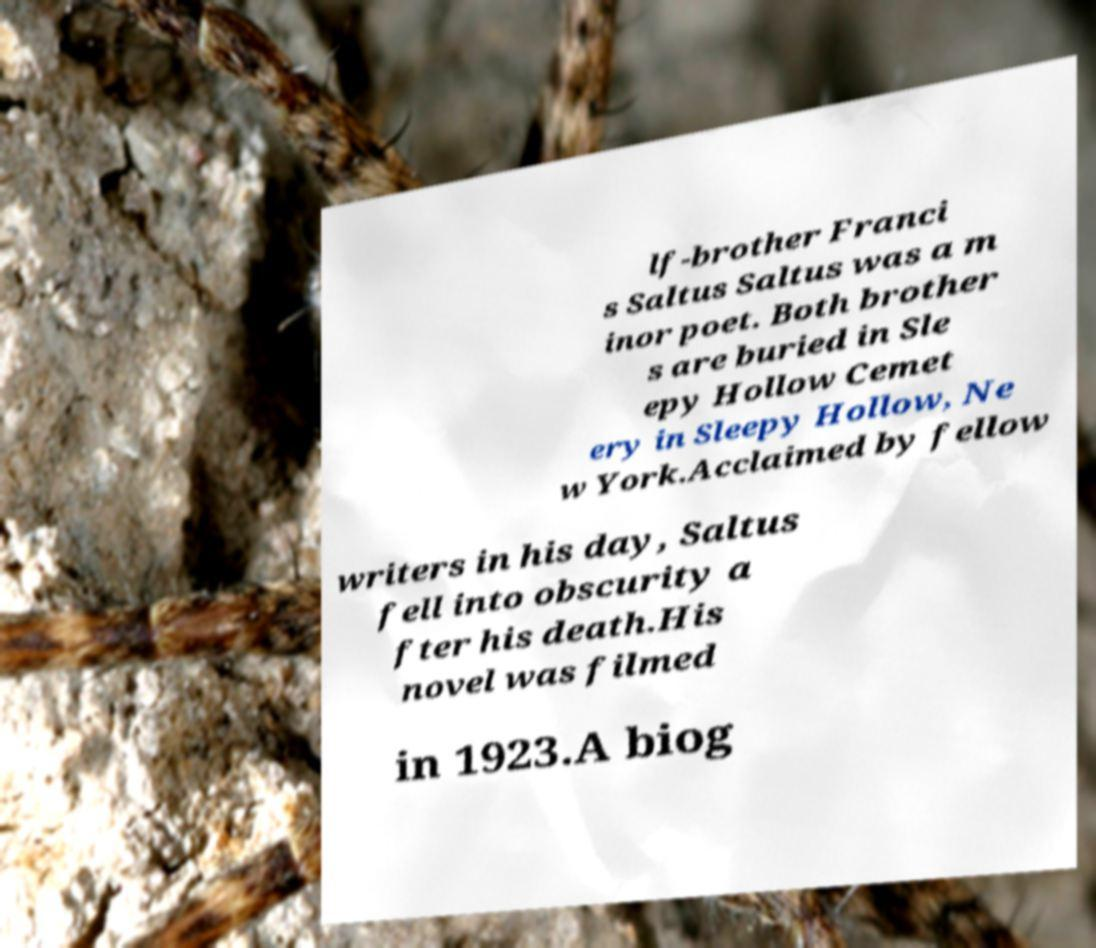Could you assist in decoding the text presented in this image and type it out clearly? lf-brother Franci s Saltus Saltus was a m inor poet. Both brother s are buried in Sle epy Hollow Cemet ery in Sleepy Hollow, Ne w York.Acclaimed by fellow writers in his day, Saltus fell into obscurity a fter his death.His novel was filmed in 1923.A biog 